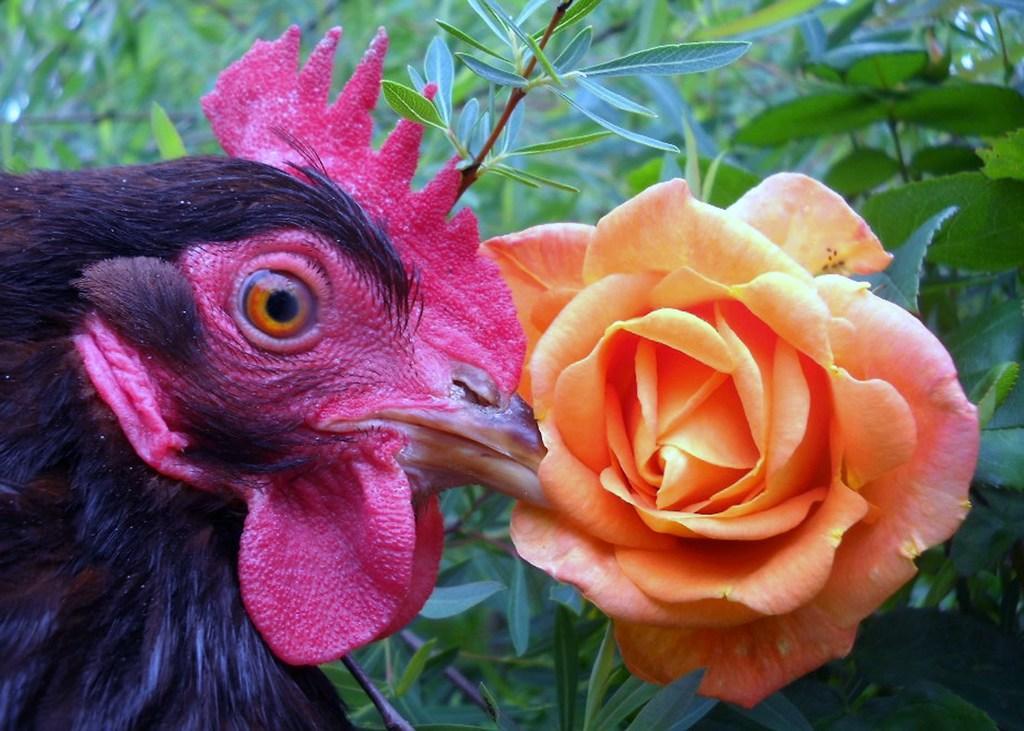Describe this image in one or two sentences. In the image on the left side there is a cock. In front of the cock there is a rose. Behind them there are stems with leaves. 